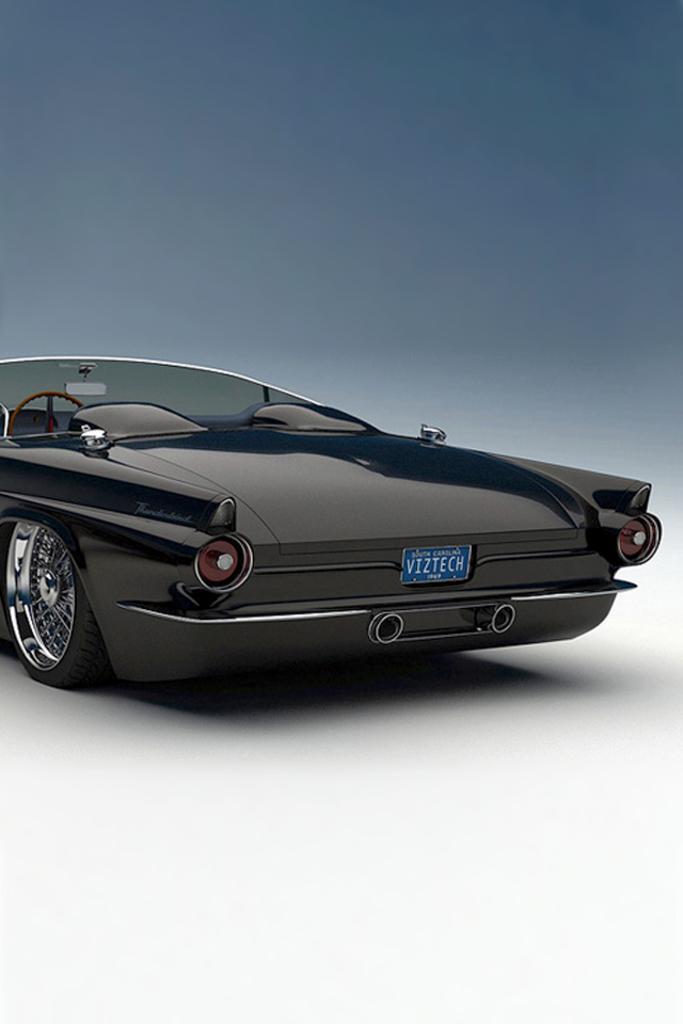Please provide a concise description of this image. In this picture we can see a car on a white color platform and in the background we can see gray color. 